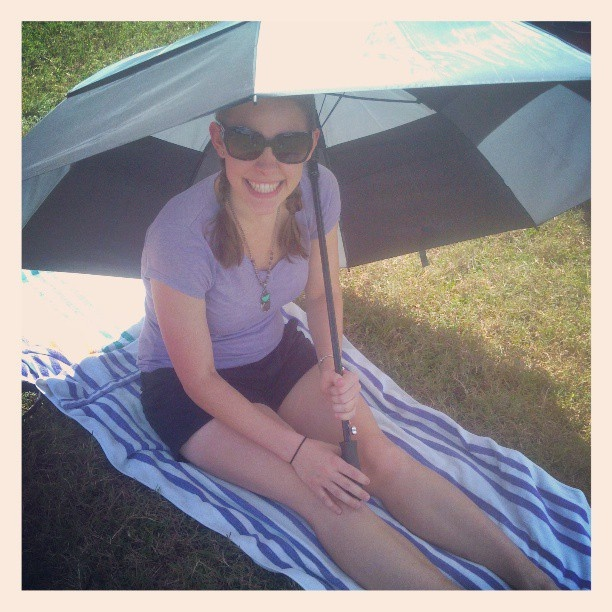Describe the objects in this image and their specific colors. I can see umbrella in white, gray, ivory, and darkgray tones and people in ivory and gray tones in this image. 